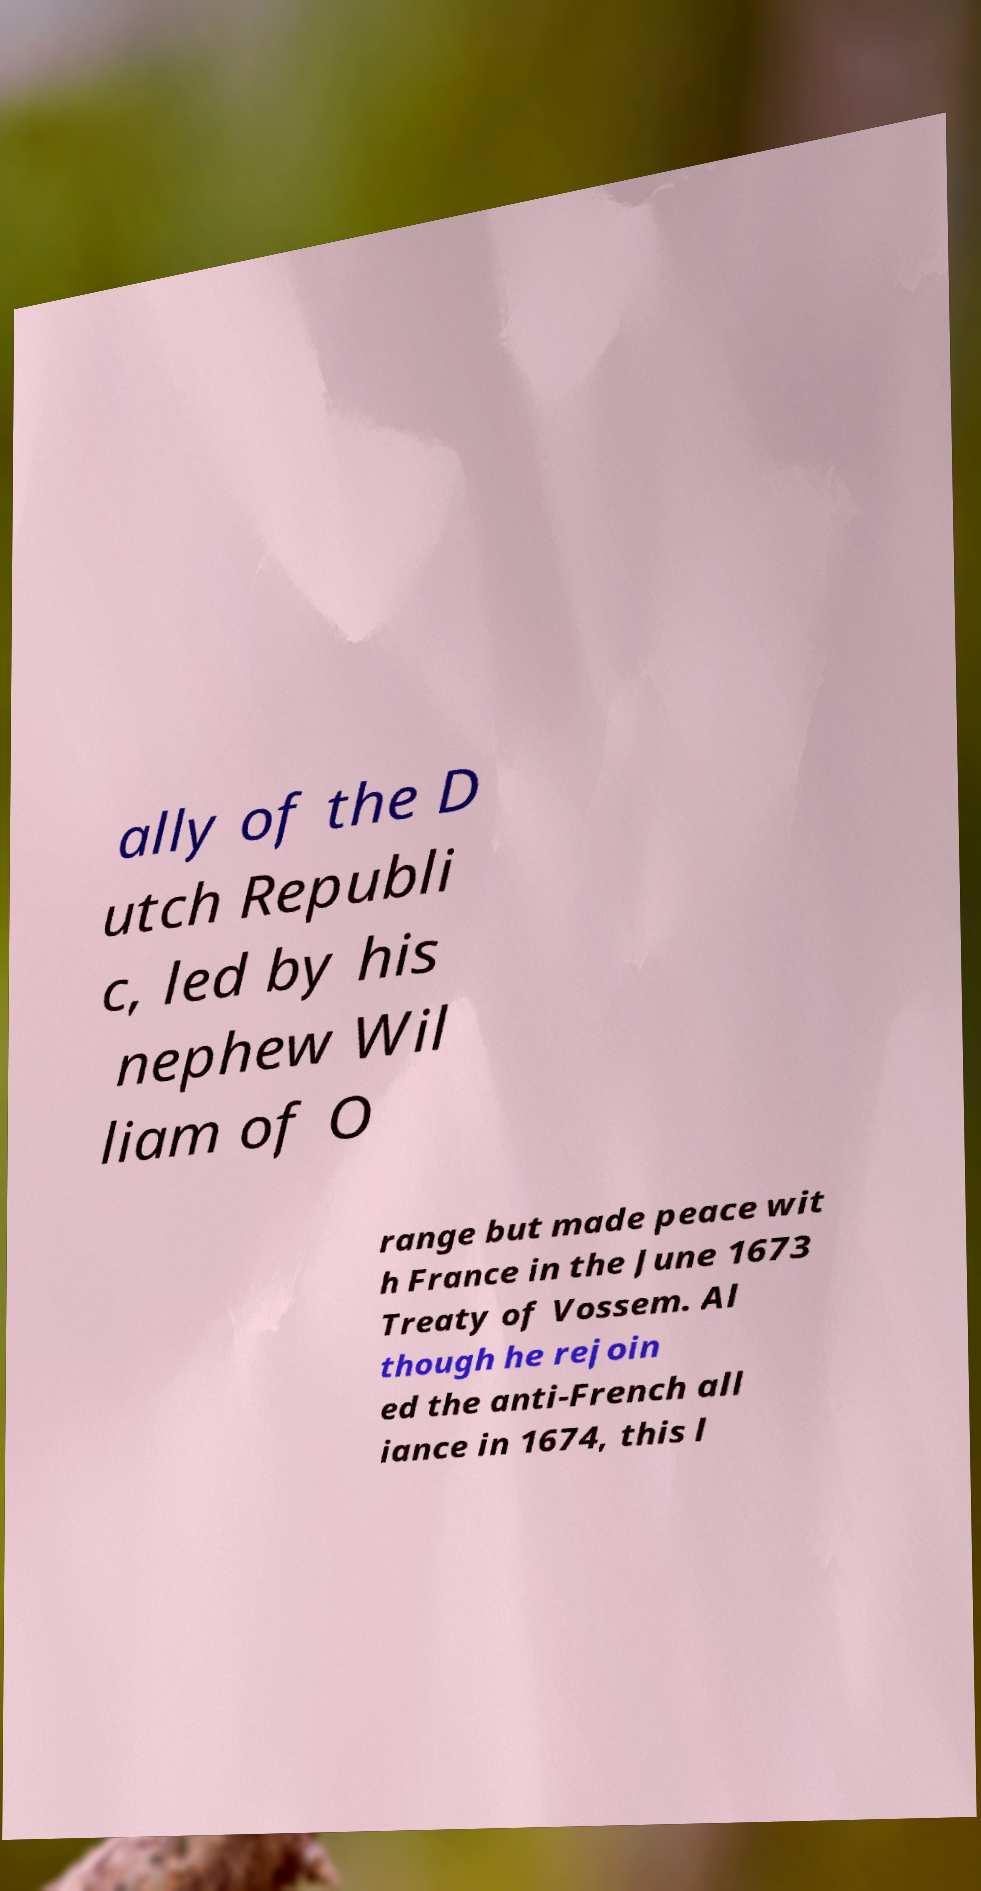I need the written content from this picture converted into text. Can you do that? ally of the D utch Republi c, led by his nephew Wil liam of O range but made peace wit h France in the June 1673 Treaty of Vossem. Al though he rejoin ed the anti-French all iance in 1674, this l 